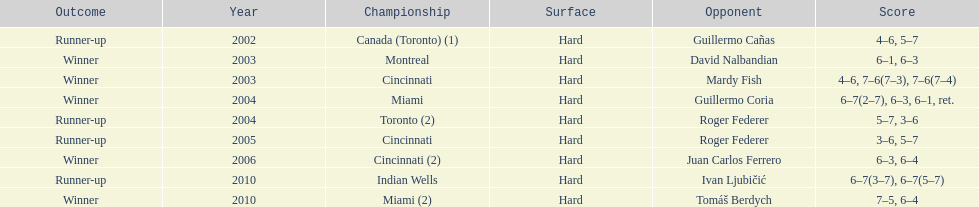How many times has he secured the runner-up position? 4. 